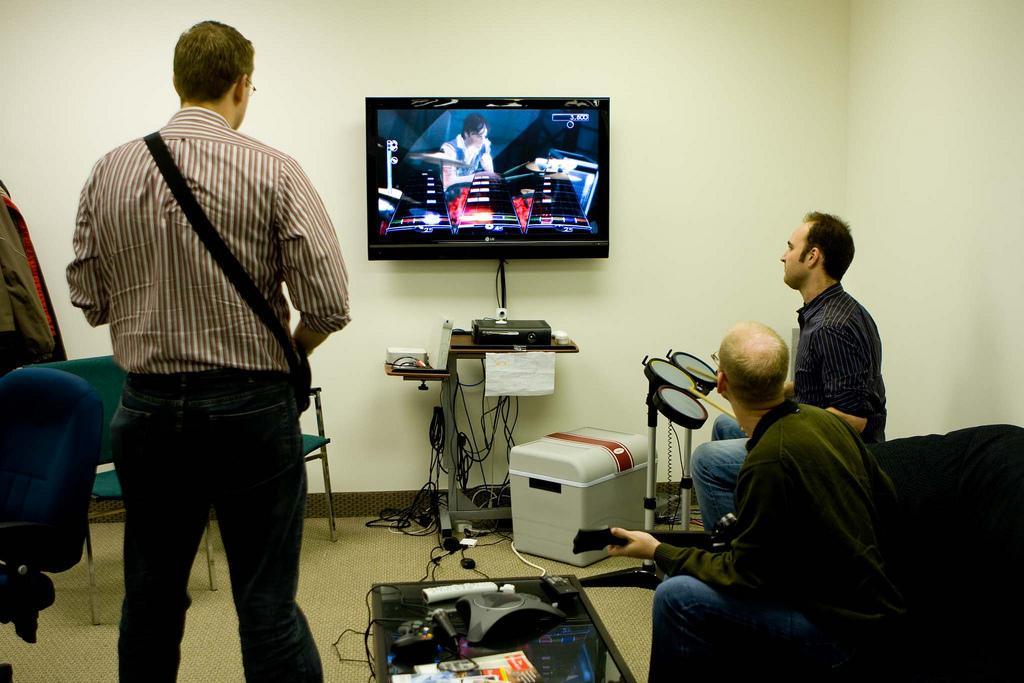In one or two sentences, can you explain what this image depicts? In the picture we can find a three persons, One man is standing and two men are sitting on a chair. In the background we can find a wall and a television. which is fixed to it. Just under the television we can find a set top box and some wires with stand and we can also find a box and we can find some chair which is green in colour and some are blue. 